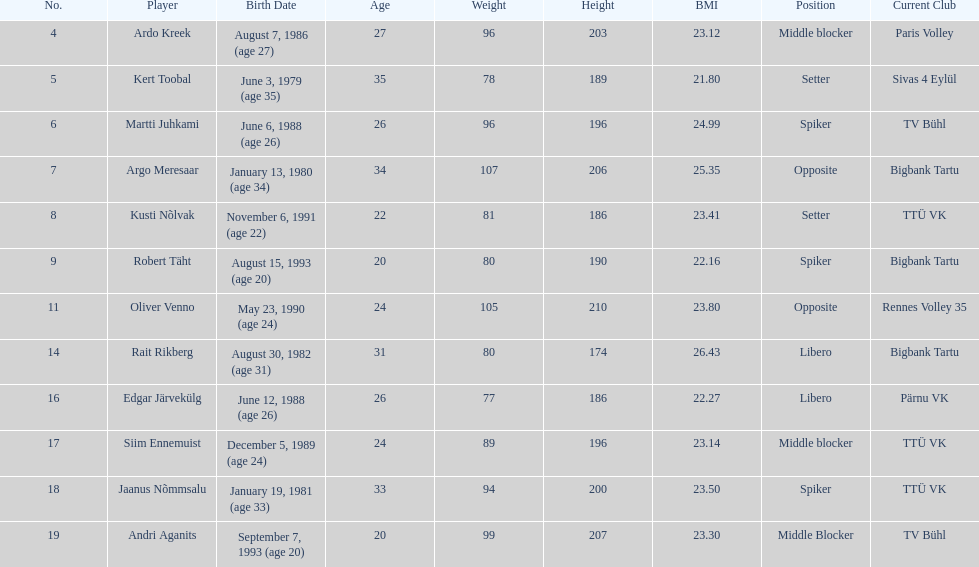Who is at least 25 years or older? Ardo Kreek, Kert Toobal, Martti Juhkami, Argo Meresaar, Rait Rikberg, Edgar Järvekülg, Jaanus Nõmmsalu. 